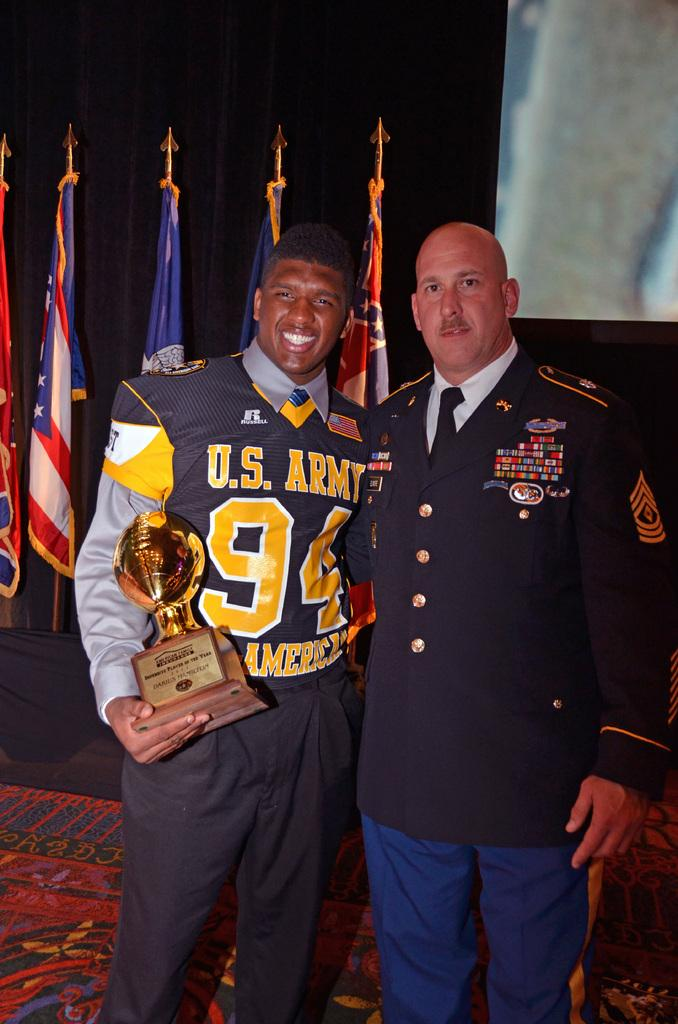<image>
Write a terse but informative summary of the picture. Two men standing together in military uniforms with U.S. Army on the shirt. 